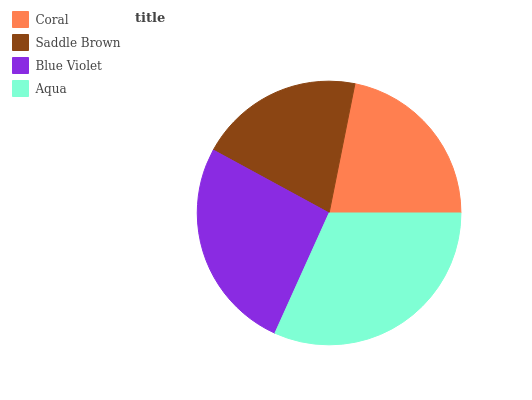Is Saddle Brown the minimum?
Answer yes or no. Yes. Is Aqua the maximum?
Answer yes or no. Yes. Is Blue Violet the minimum?
Answer yes or no. No. Is Blue Violet the maximum?
Answer yes or no. No. Is Blue Violet greater than Saddle Brown?
Answer yes or no. Yes. Is Saddle Brown less than Blue Violet?
Answer yes or no. Yes. Is Saddle Brown greater than Blue Violet?
Answer yes or no. No. Is Blue Violet less than Saddle Brown?
Answer yes or no. No. Is Blue Violet the high median?
Answer yes or no. Yes. Is Coral the low median?
Answer yes or no. Yes. Is Aqua the high median?
Answer yes or no. No. Is Saddle Brown the low median?
Answer yes or no. No. 